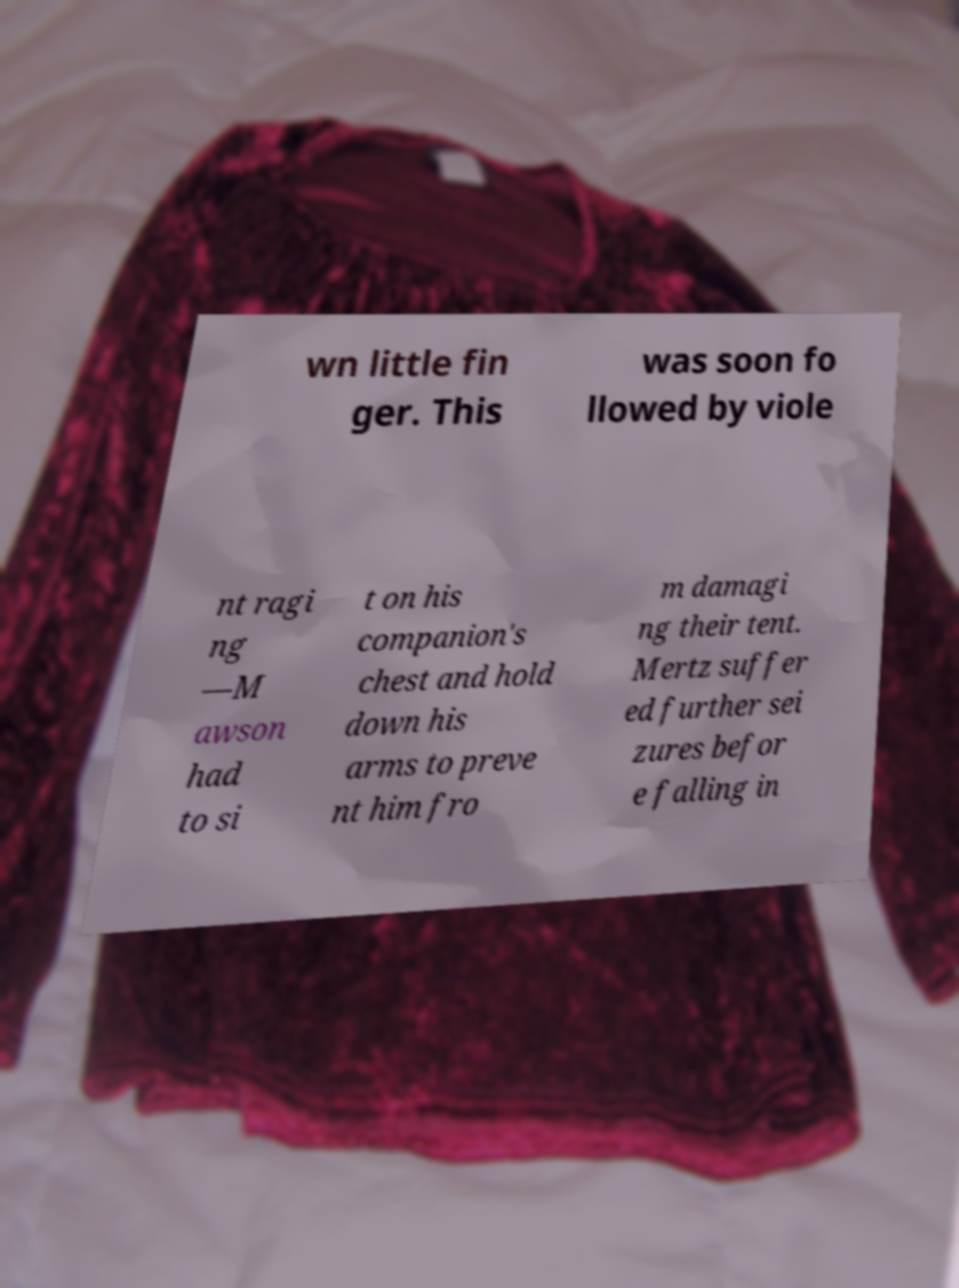For documentation purposes, I need the text within this image transcribed. Could you provide that? wn little fin ger. This was soon fo llowed by viole nt ragi ng —M awson had to si t on his companion's chest and hold down his arms to preve nt him fro m damagi ng their tent. Mertz suffer ed further sei zures befor e falling in 